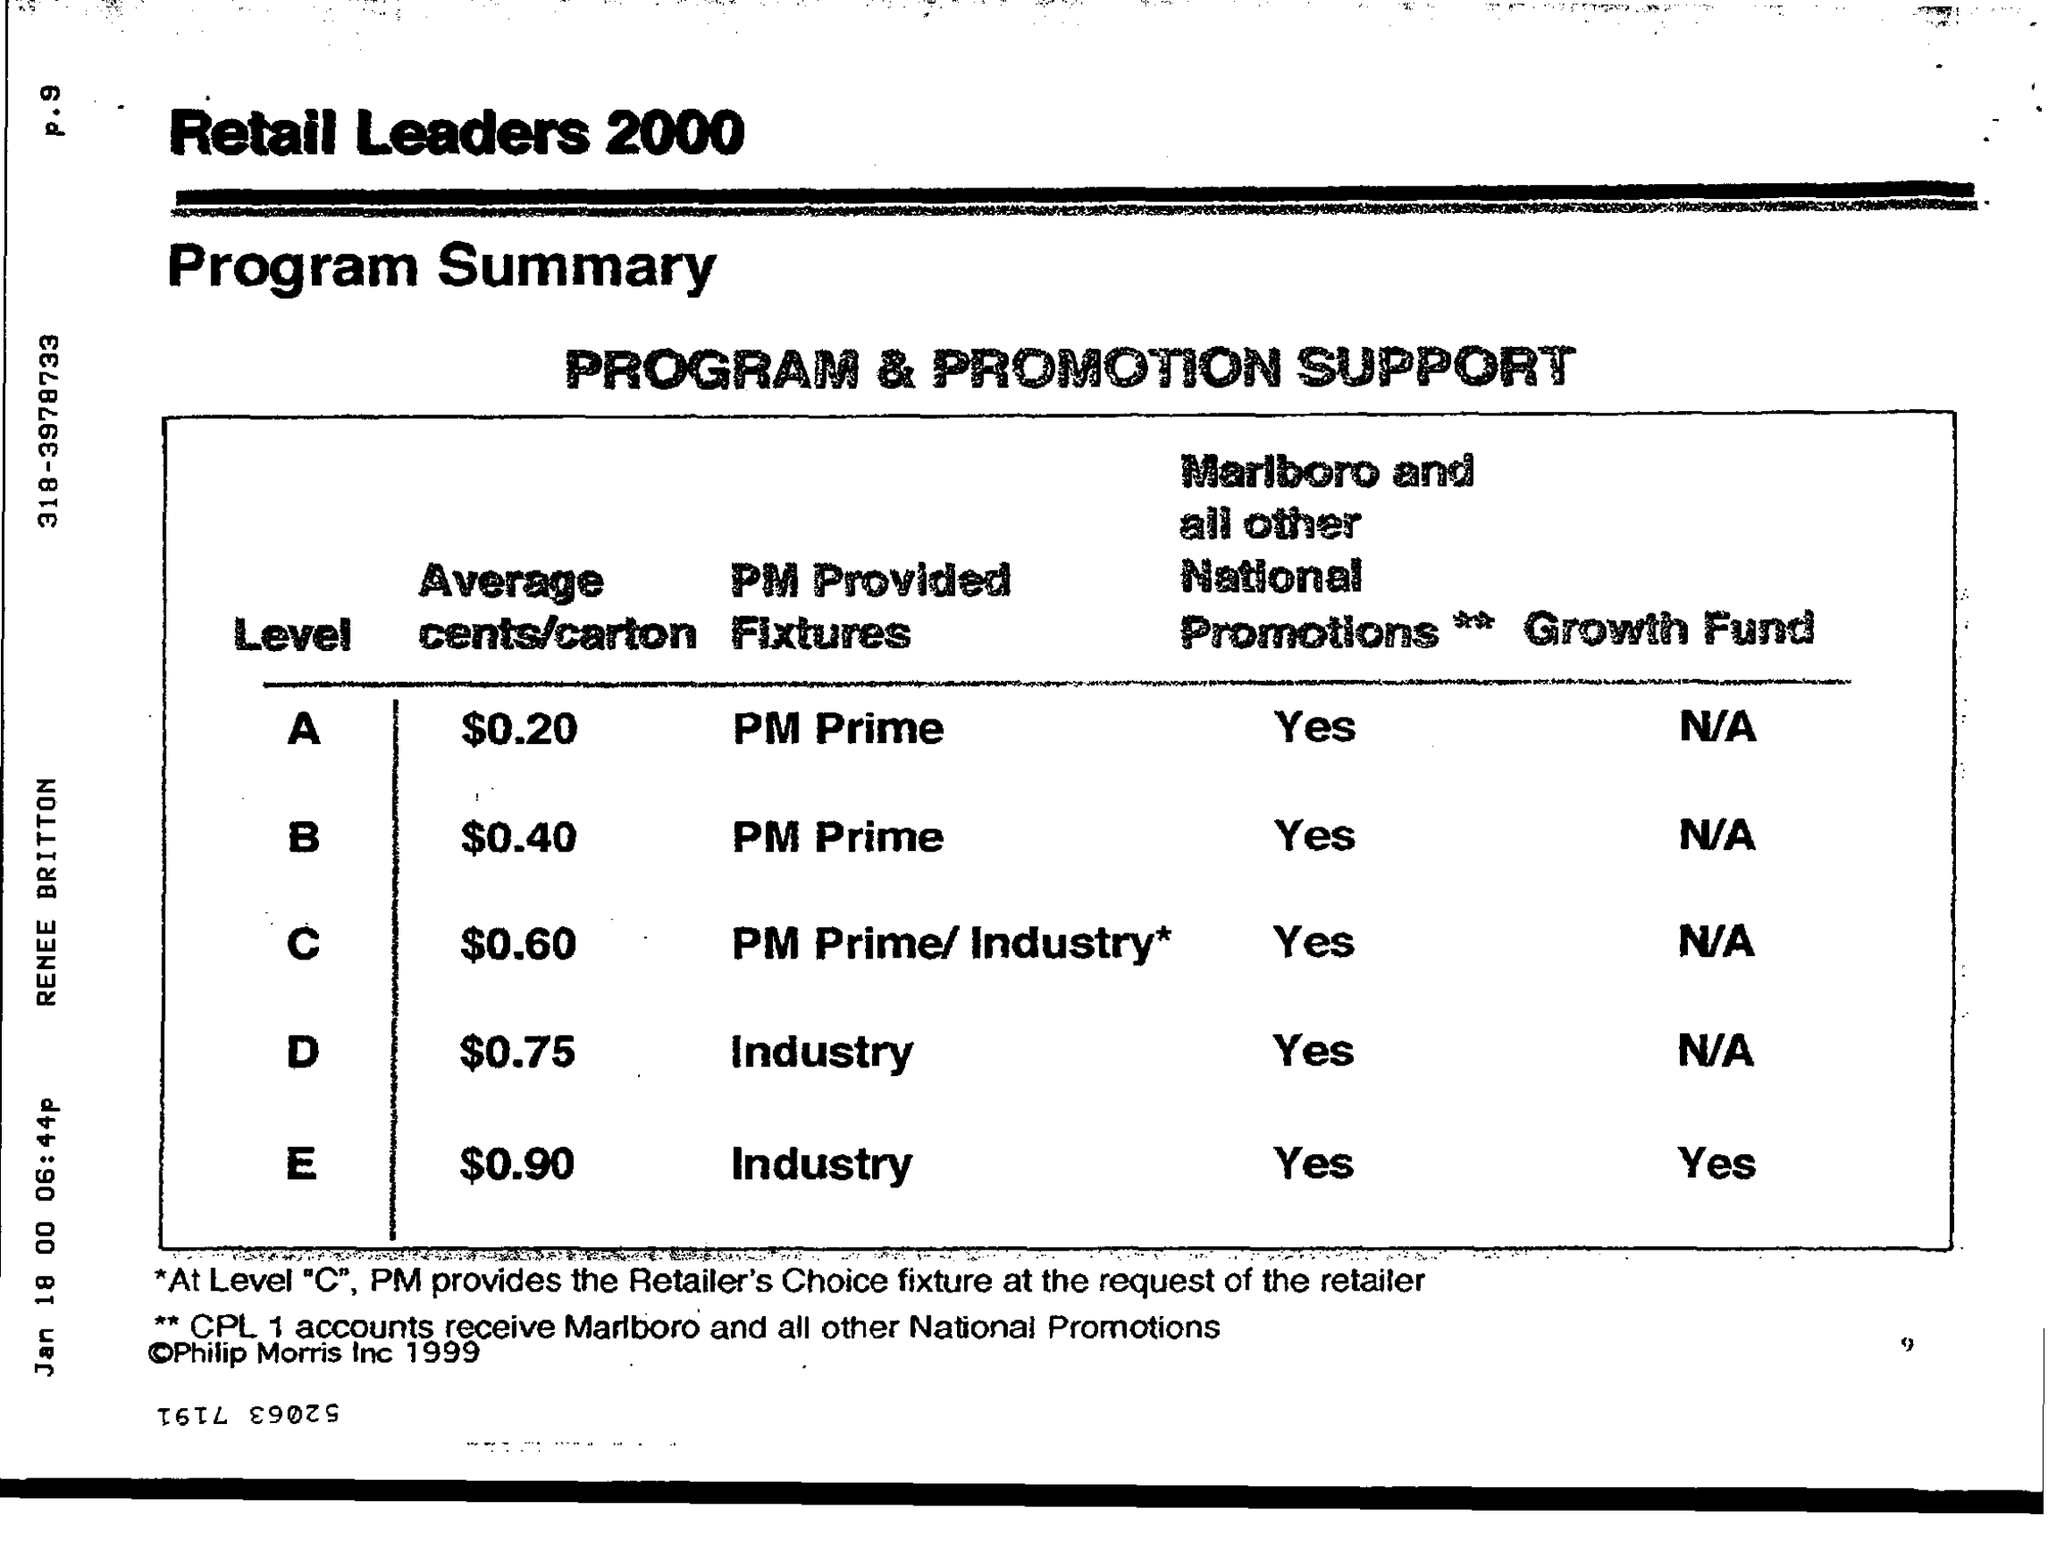What is the value of average cents/carton for level a ?
Your response must be concise. $ 0.20. What is the value of average cents/carton for level d ?
Make the answer very short. $0.75. What is the status of growth fund for level e ?
Offer a terse response. Yes. What is the pm provided fixtures for level b?
Make the answer very short. PM Prime. 